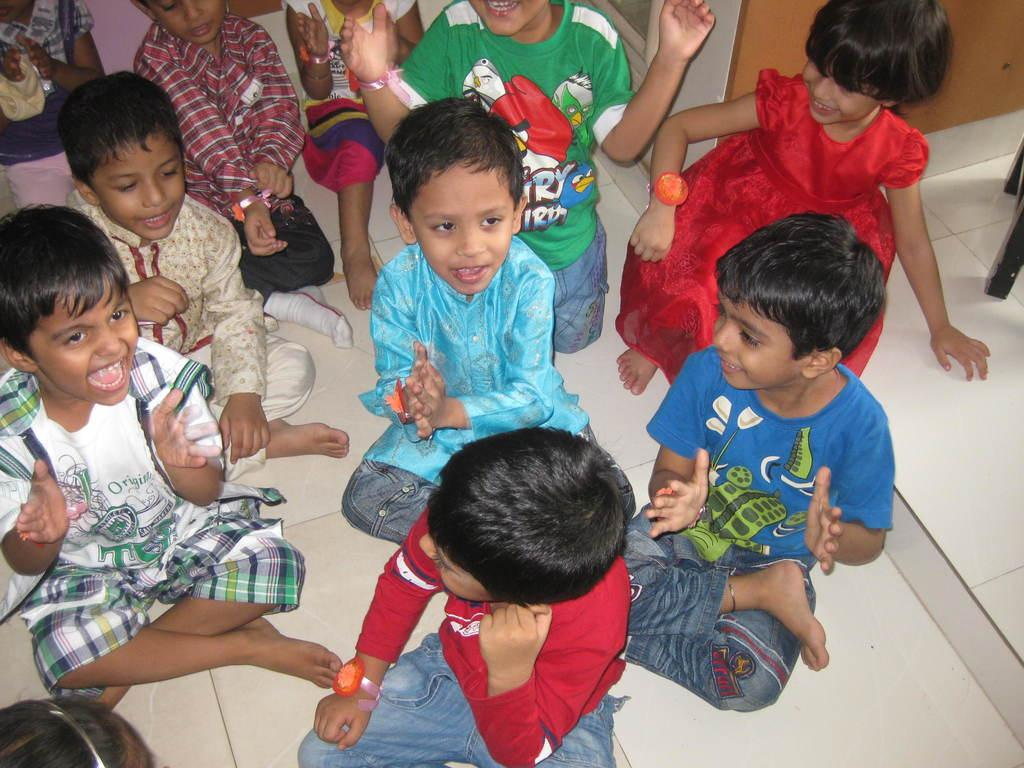Who is present in the image? There are kids in the image. What are the kids doing in the image? The kids are sitting on the floor and clapping. What type of crow can be seen in the image? There is no crow present in the image. What color is the apple that the kids are holding in the image? There are no apples present in the image. 